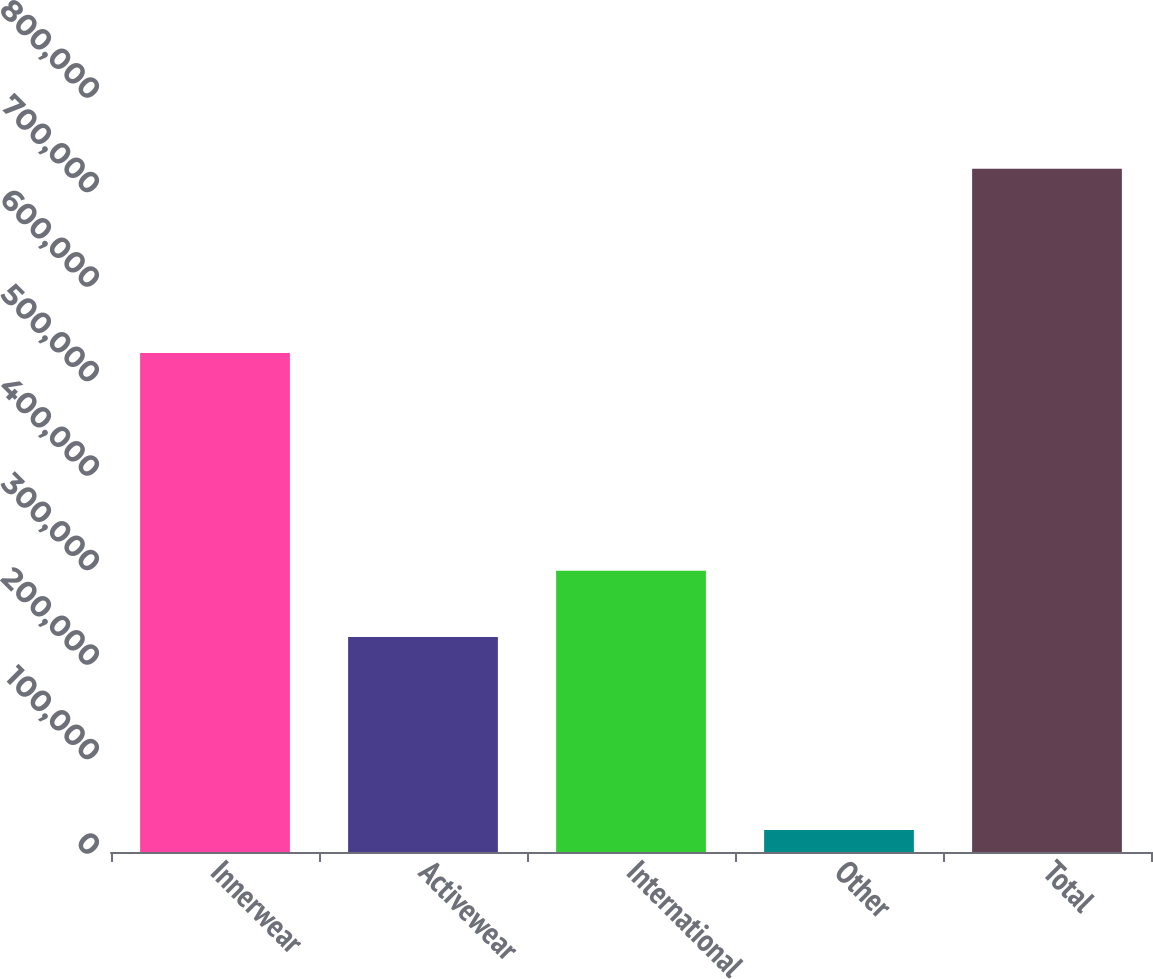Convert chart. <chart><loc_0><loc_0><loc_500><loc_500><bar_chart><fcel>Innerwear<fcel>Activewear<fcel>International<fcel>Other<fcel>Total<nl><fcel>528038<fcel>227589<fcel>297559<fcel>23364<fcel>723068<nl></chart> 